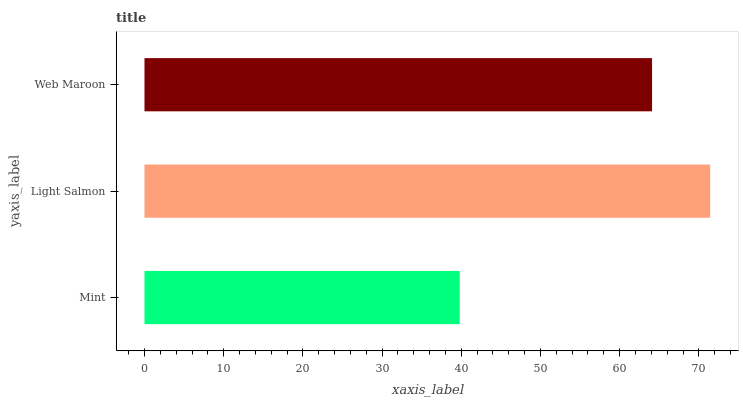Is Mint the minimum?
Answer yes or no. Yes. Is Light Salmon the maximum?
Answer yes or no. Yes. Is Web Maroon the minimum?
Answer yes or no. No. Is Web Maroon the maximum?
Answer yes or no. No. Is Light Salmon greater than Web Maroon?
Answer yes or no. Yes. Is Web Maroon less than Light Salmon?
Answer yes or no. Yes. Is Web Maroon greater than Light Salmon?
Answer yes or no. No. Is Light Salmon less than Web Maroon?
Answer yes or no. No. Is Web Maroon the high median?
Answer yes or no. Yes. Is Web Maroon the low median?
Answer yes or no. Yes. Is Mint the high median?
Answer yes or no. No. Is Mint the low median?
Answer yes or no. No. 